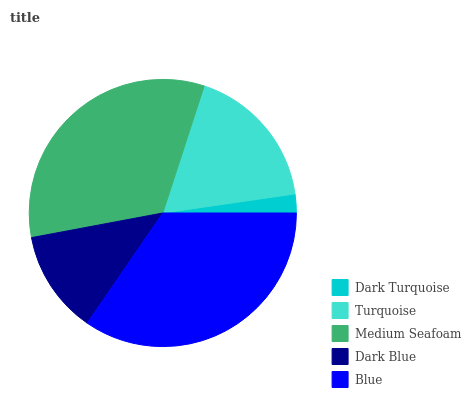Is Dark Turquoise the minimum?
Answer yes or no. Yes. Is Blue the maximum?
Answer yes or no. Yes. Is Turquoise the minimum?
Answer yes or no. No. Is Turquoise the maximum?
Answer yes or no. No. Is Turquoise greater than Dark Turquoise?
Answer yes or no. Yes. Is Dark Turquoise less than Turquoise?
Answer yes or no. Yes. Is Dark Turquoise greater than Turquoise?
Answer yes or no. No. Is Turquoise less than Dark Turquoise?
Answer yes or no. No. Is Turquoise the high median?
Answer yes or no. Yes. Is Turquoise the low median?
Answer yes or no. Yes. Is Dark Blue the high median?
Answer yes or no. No. Is Blue the low median?
Answer yes or no. No. 